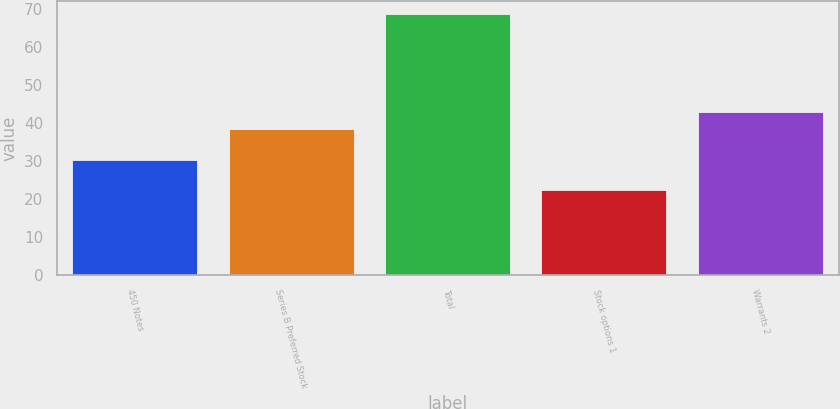Convert chart to OTSL. <chart><loc_0><loc_0><loc_500><loc_500><bar_chart><fcel>450 Notes<fcel>Series B Preferred Stock<fcel>Total<fcel>Stock options 1<fcel>Warrants 2<nl><fcel>30.2<fcel>38.4<fcel>68.6<fcel>22.4<fcel>43.02<nl></chart> 